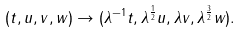<formula> <loc_0><loc_0><loc_500><loc_500>( t , u , v , w ) \rightarrow ( { \lambda } ^ { - 1 } t , \lambda ^ { \frac { 1 } { 2 } } u , \lambda v , \lambda ^ { \frac { 3 } { 2 } } w ) .</formula> 